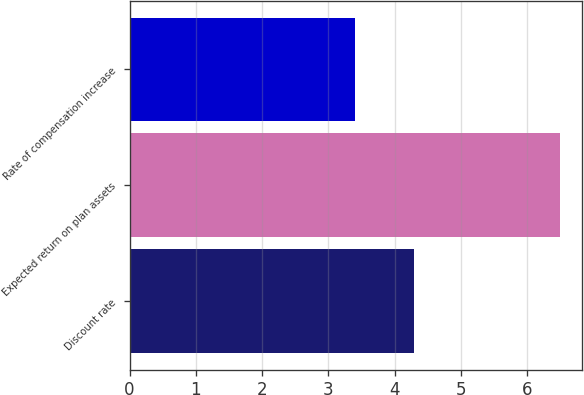Convert chart. <chart><loc_0><loc_0><loc_500><loc_500><bar_chart><fcel>Discount rate<fcel>Expected return on plan assets<fcel>Rate of compensation increase<nl><fcel>4.3<fcel>6.5<fcel>3.4<nl></chart> 